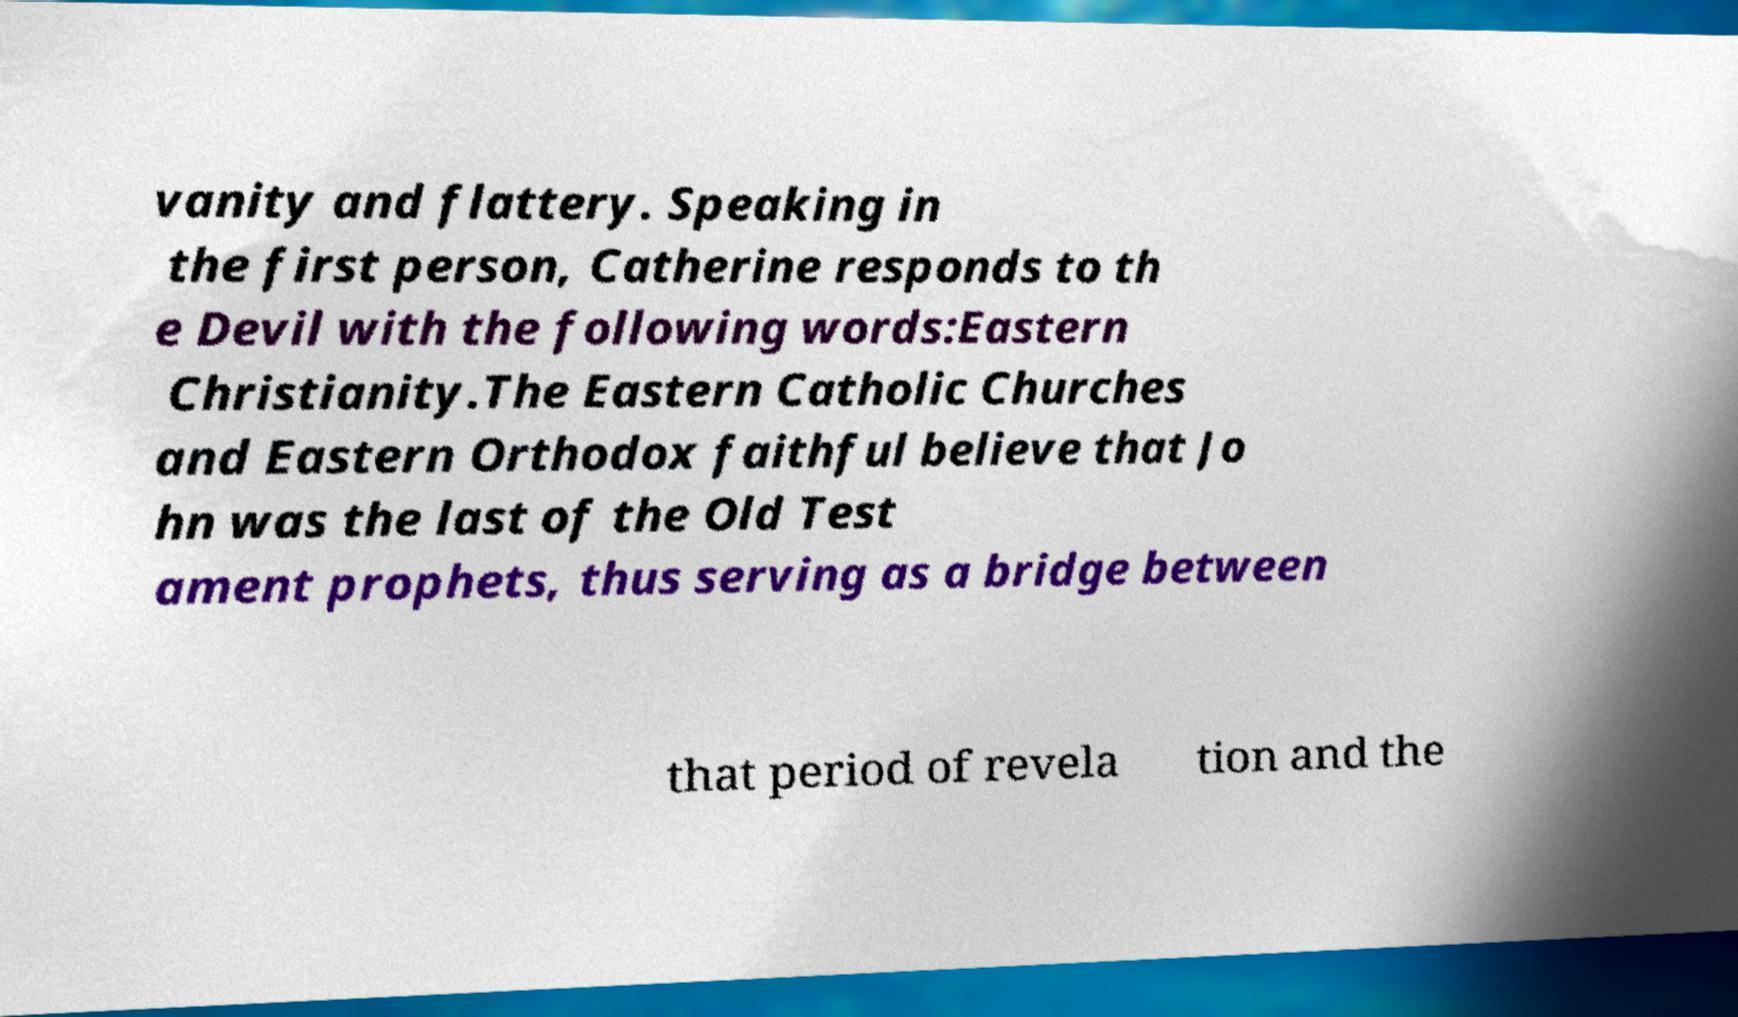Please identify and transcribe the text found in this image. vanity and flattery. Speaking in the first person, Catherine responds to th e Devil with the following words:Eastern Christianity.The Eastern Catholic Churches and Eastern Orthodox faithful believe that Jo hn was the last of the Old Test ament prophets, thus serving as a bridge between that period of revela tion and the 